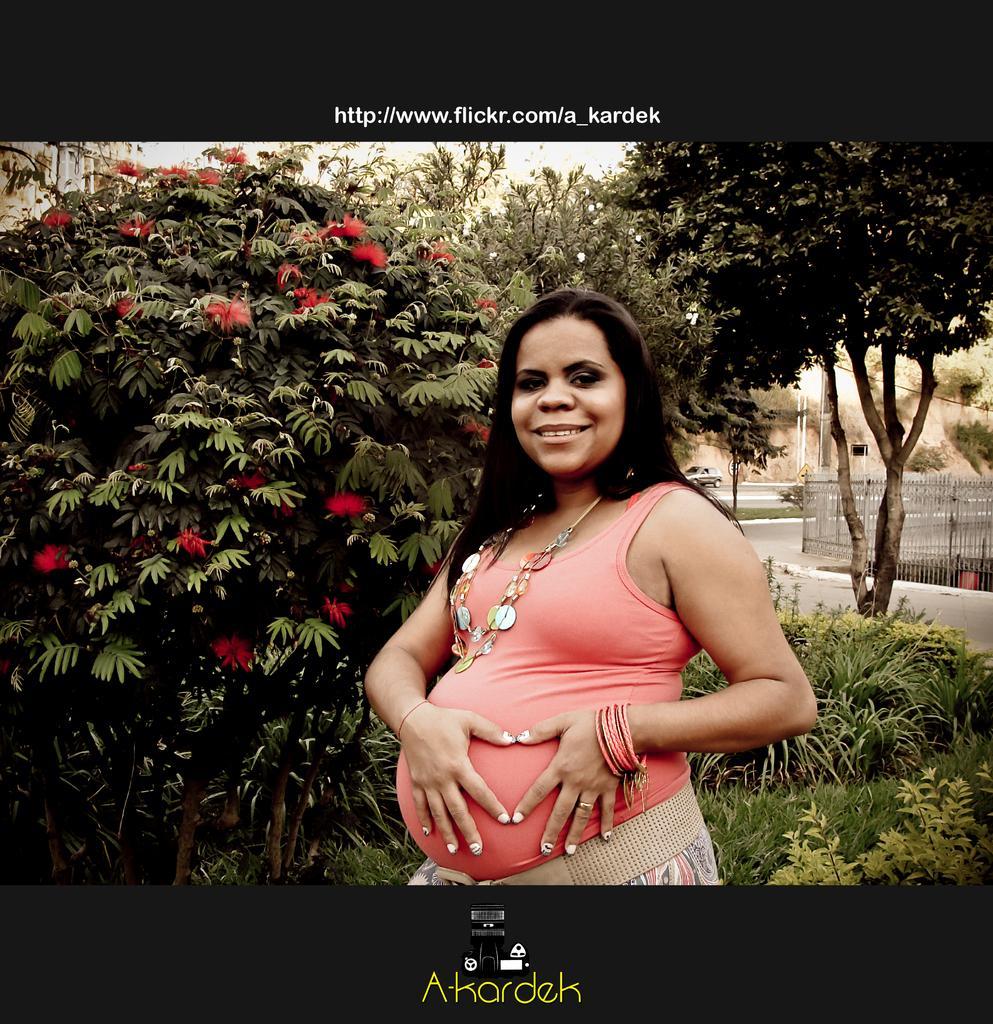Could you give a brief overview of what you see in this image? In this picture we can see a woman smiling and in the background we can see fence, trees, car on the road. 